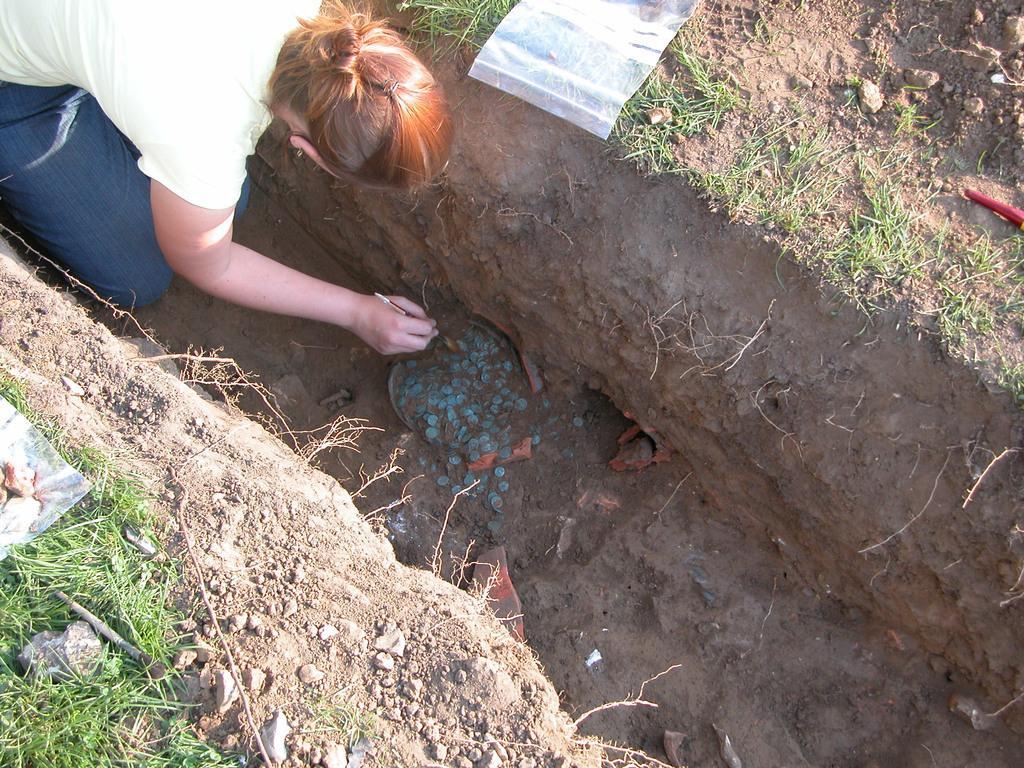In one or two sentences, can you explain what this image depicts? In this image there is a lady checking with the stones which are on the pit, beside them there is a cover on the ground. 